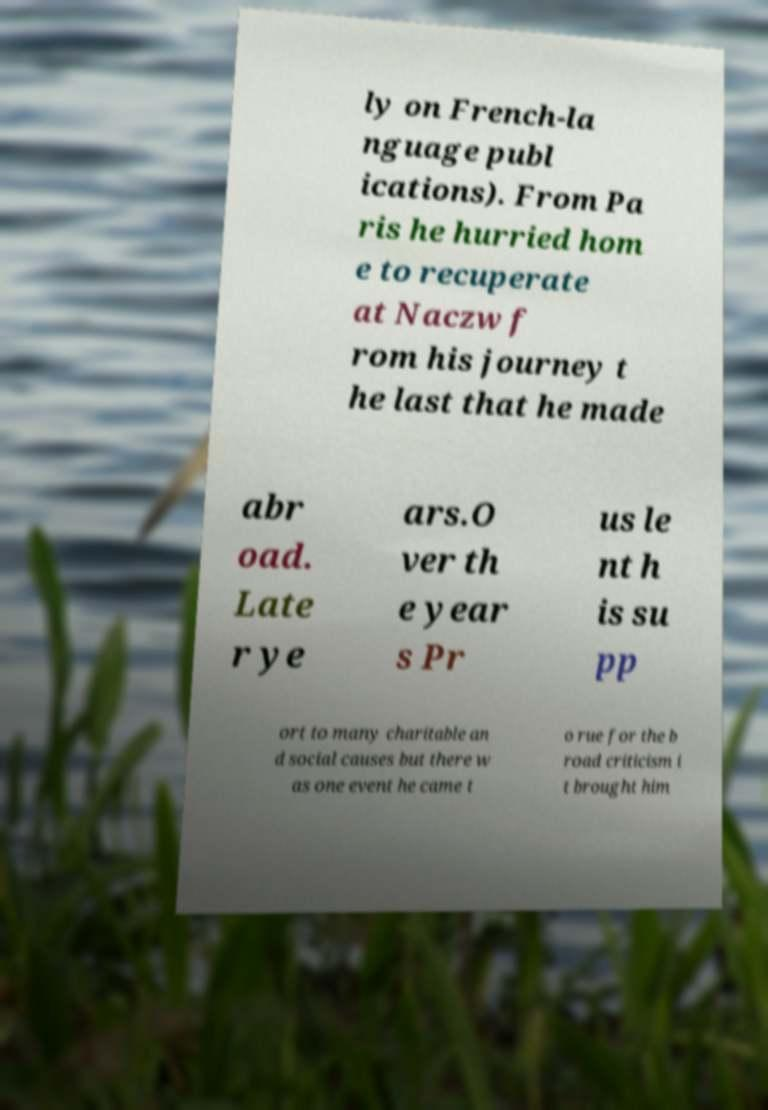What messages or text are displayed in this image? I need them in a readable, typed format. ly on French-la nguage publ ications). From Pa ris he hurried hom e to recuperate at Naczw f rom his journey t he last that he made abr oad. Late r ye ars.O ver th e year s Pr us le nt h is su pp ort to many charitable an d social causes but there w as one event he came t o rue for the b road criticism i t brought him 